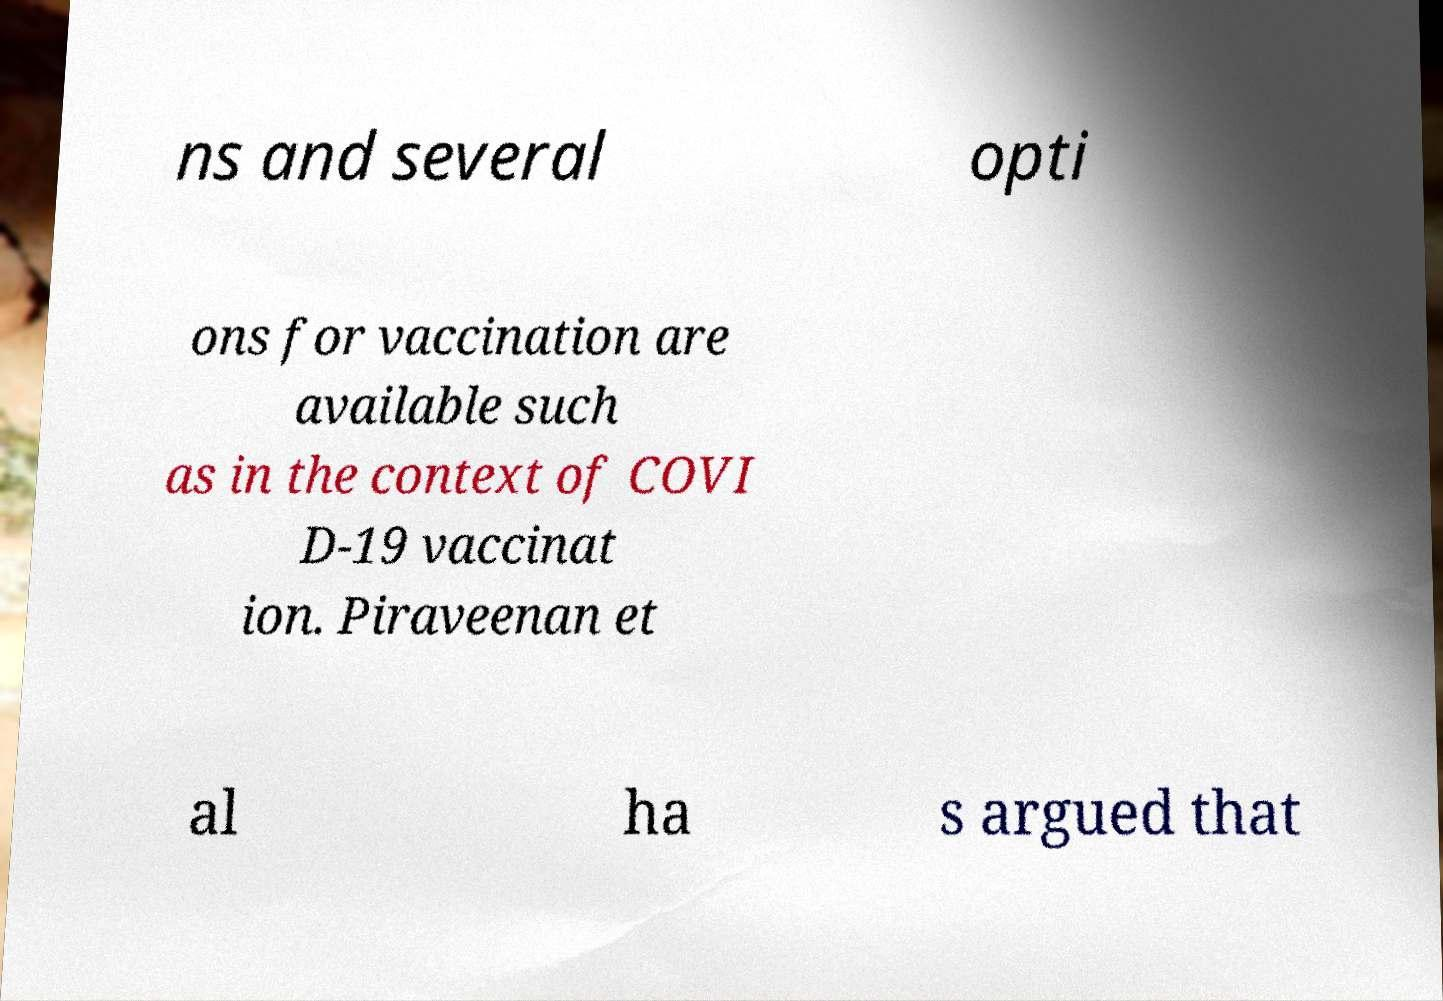For documentation purposes, I need the text within this image transcribed. Could you provide that? ns and several opti ons for vaccination are available such as in the context of COVI D-19 vaccinat ion. Piraveenan et al ha s argued that 